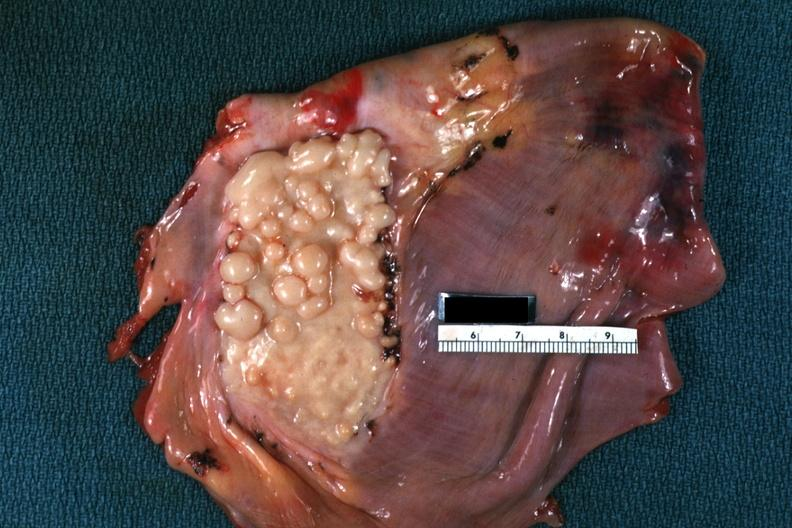s soft tissue present?
Answer the question using a single word or phrase. Yes 